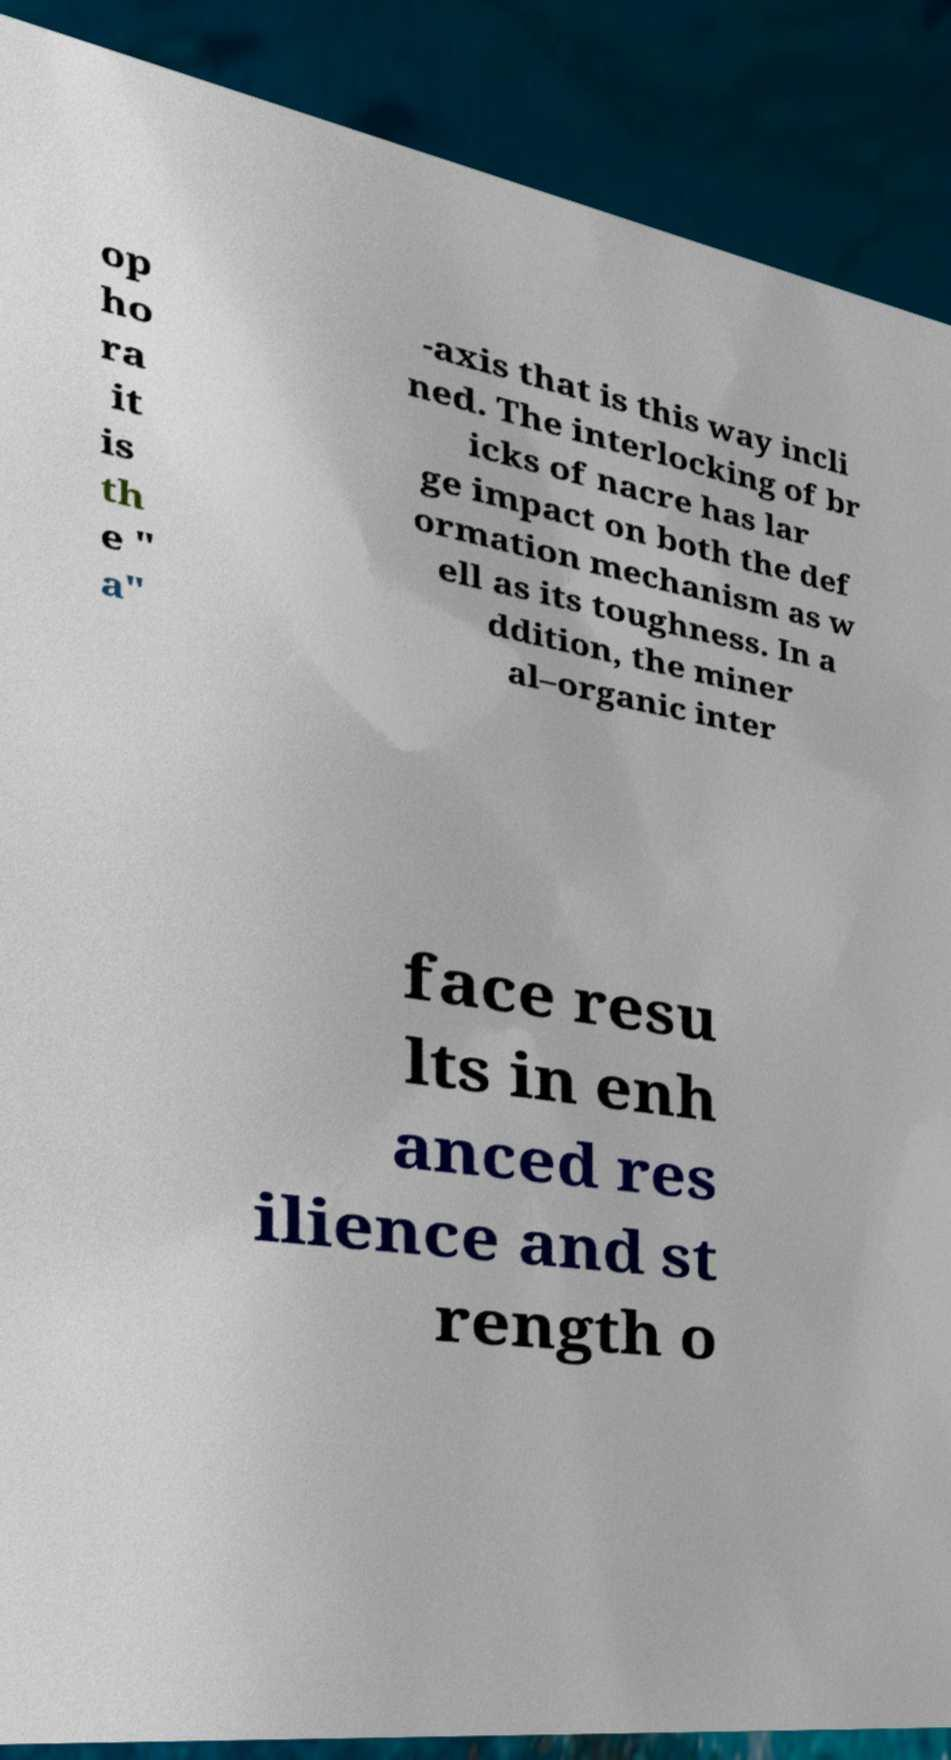I need the written content from this picture converted into text. Can you do that? op ho ra it is th e " a" -axis that is this way incli ned. The interlocking of br icks of nacre has lar ge impact on both the def ormation mechanism as w ell as its toughness. In a ddition, the miner al–organic inter face resu lts in enh anced res ilience and st rength o 